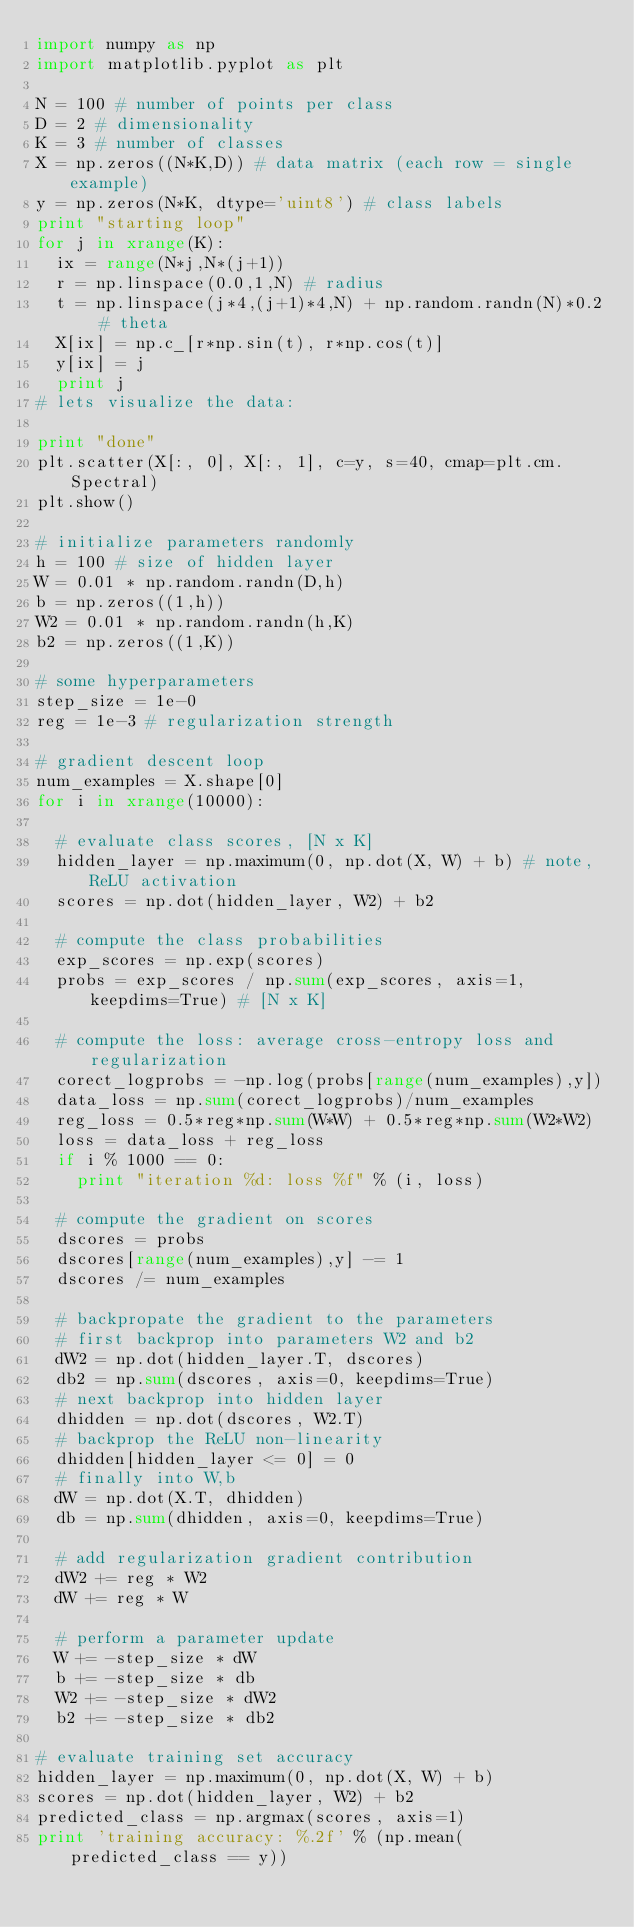Convert code to text. <code><loc_0><loc_0><loc_500><loc_500><_Python_>import numpy as np
import matplotlib.pyplot as plt

N = 100 # number of points per class
D = 2 # dimensionality
K = 3 # number of classes
X = np.zeros((N*K,D)) # data matrix (each row = single example)
y = np.zeros(N*K, dtype='uint8') # class labels
print "starting loop"
for j in xrange(K):
  ix = range(N*j,N*(j+1))
  r = np.linspace(0.0,1,N) # radius
  t = np.linspace(j*4,(j+1)*4,N) + np.random.randn(N)*0.2 # theta
  X[ix] = np.c_[r*np.sin(t), r*np.cos(t)]
  y[ix] = j
  print j
# lets visualize the data:

print "done"
plt.scatter(X[:, 0], X[:, 1], c=y, s=40, cmap=plt.cm.Spectral)
plt.show()

# initialize parameters randomly
h = 100 # size of hidden layer
W = 0.01 * np.random.randn(D,h)
b = np.zeros((1,h))
W2 = 0.01 * np.random.randn(h,K)
b2 = np.zeros((1,K))

# some hyperparameters
step_size = 1e-0
reg = 1e-3 # regularization strength

# gradient descent loop
num_examples = X.shape[0]
for i in xrange(10000):

  # evaluate class scores, [N x K]
  hidden_layer = np.maximum(0, np.dot(X, W) + b) # note, ReLU activation
  scores = np.dot(hidden_layer, W2) + b2

  # compute the class probabilities
  exp_scores = np.exp(scores)
  probs = exp_scores / np.sum(exp_scores, axis=1, keepdims=True) # [N x K]

  # compute the loss: average cross-entropy loss and regularization
  corect_logprobs = -np.log(probs[range(num_examples),y])
  data_loss = np.sum(corect_logprobs)/num_examples
  reg_loss = 0.5*reg*np.sum(W*W) + 0.5*reg*np.sum(W2*W2)
  loss = data_loss + reg_loss
  if i % 1000 == 0:
    print "iteration %d: loss %f" % (i, loss)

  # compute the gradient on scores
  dscores = probs
  dscores[range(num_examples),y] -= 1
  dscores /= num_examples

  # backpropate the gradient to the parameters
  # first backprop into parameters W2 and b2
  dW2 = np.dot(hidden_layer.T, dscores)
  db2 = np.sum(dscores, axis=0, keepdims=True)
  # next backprop into hidden layer
  dhidden = np.dot(dscores, W2.T)
  # backprop the ReLU non-linearity
  dhidden[hidden_layer <= 0] = 0
  # finally into W,b
  dW = np.dot(X.T, dhidden)
  db = np.sum(dhidden, axis=0, keepdims=True)

  # add regularization gradient contribution
  dW2 += reg * W2
  dW += reg * W

  # perform a parameter update
  W += -step_size * dW
  b += -step_size * db
  W2 += -step_size * dW2
  b2 += -step_size * db2
  
# evaluate training set accuracy
hidden_layer = np.maximum(0, np.dot(X, W) + b)
scores = np.dot(hidden_layer, W2) + b2
predicted_class = np.argmax(scores, axis=1)
print 'training accuracy: %.2f' % (np.mean(predicted_class == y))</code> 